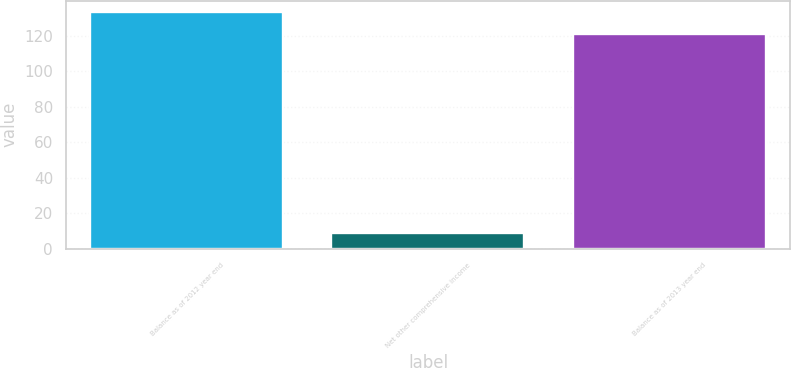Convert chart to OTSL. <chart><loc_0><loc_0><loc_500><loc_500><bar_chart><fcel>Balance as of 2012 year end<fcel>Net other comprehensive income<fcel>Balance as of 2013 year end<nl><fcel>133.21<fcel>8.6<fcel>121.1<nl></chart> 